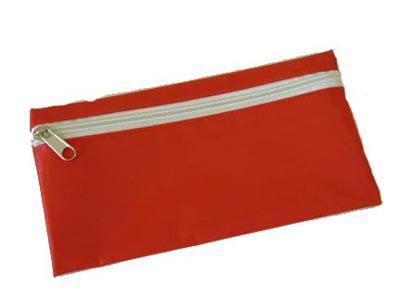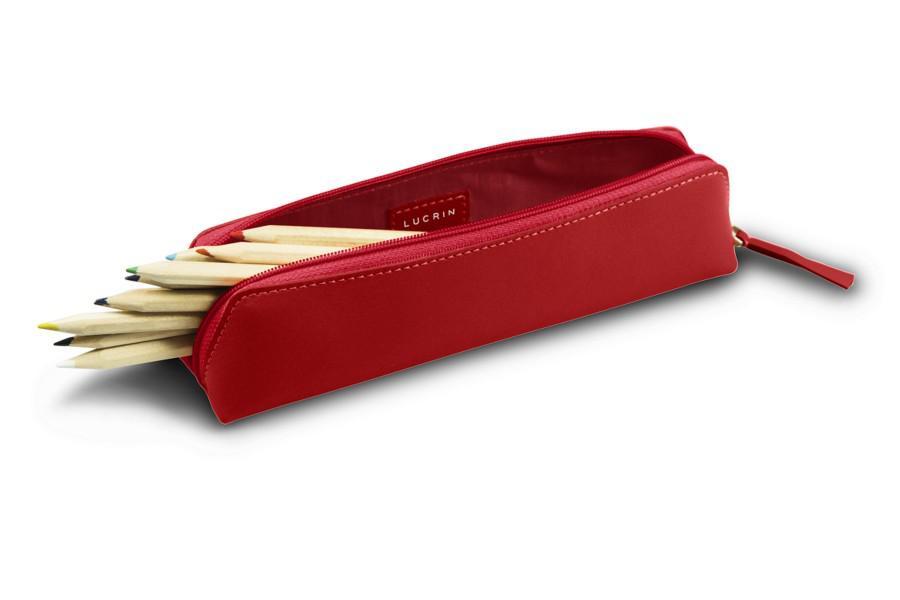The first image is the image on the left, the second image is the image on the right. Examine the images to the left and right. Is the description "There is one brand label showing on the pencil pouch on the right." accurate? Answer yes or no. No. The first image is the image on the left, the second image is the image on the right. Examine the images to the left and right. Is the description "The pencil case on the left is not flat; it's shaped more like a rectangular box." accurate? Answer yes or no. No. 